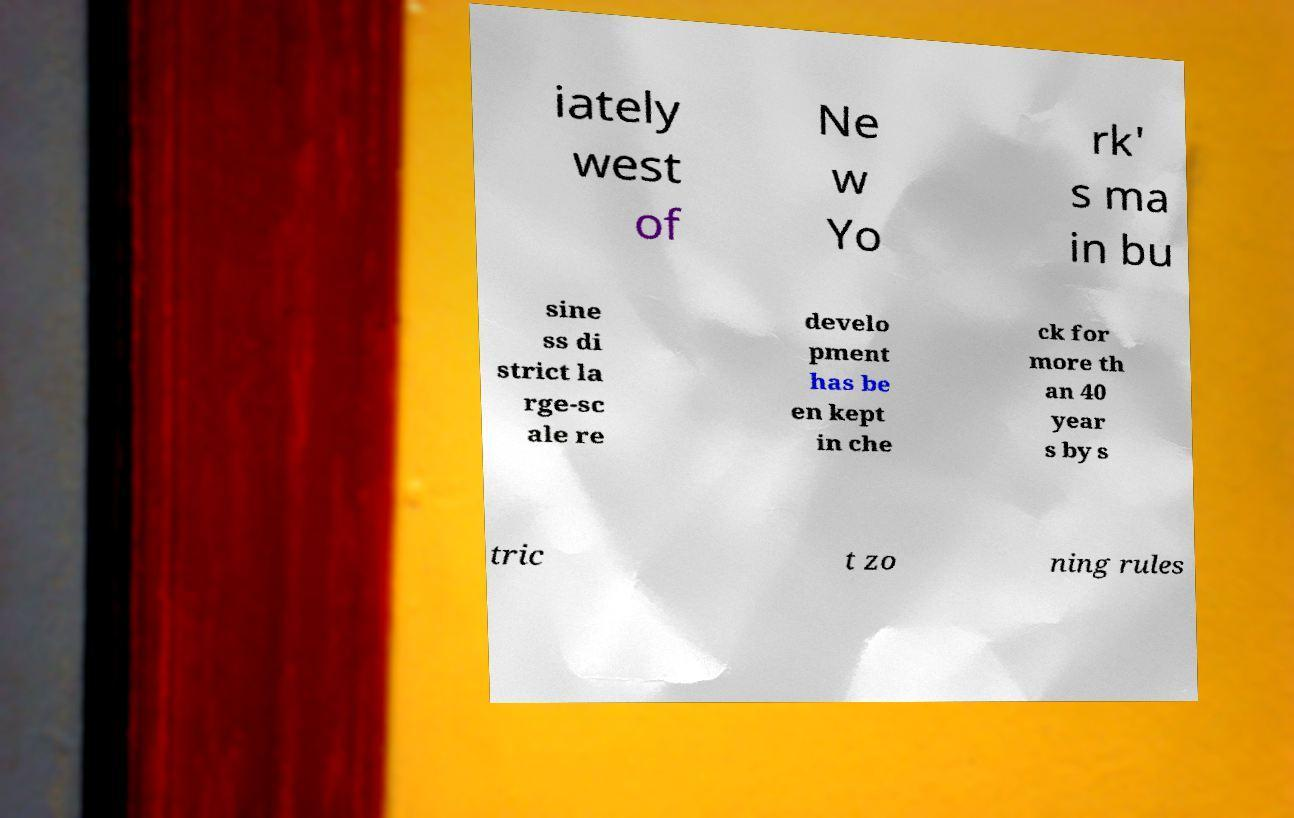Please identify and transcribe the text found in this image. iately west of Ne w Yo rk' s ma in bu sine ss di strict la rge-sc ale re develo pment has be en kept in che ck for more th an 40 year s by s tric t zo ning rules 